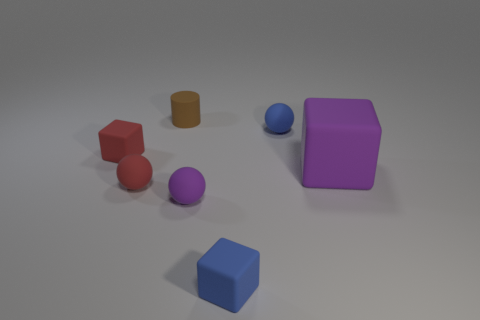Add 3 gray things. How many objects exist? 10 Subtract all cubes. How many objects are left? 4 Add 4 large rubber cubes. How many large rubber cubes exist? 5 Subtract 0 gray cylinders. How many objects are left? 7 Subtract all rubber balls. Subtract all blue rubber cubes. How many objects are left? 3 Add 3 small brown things. How many small brown things are left? 4 